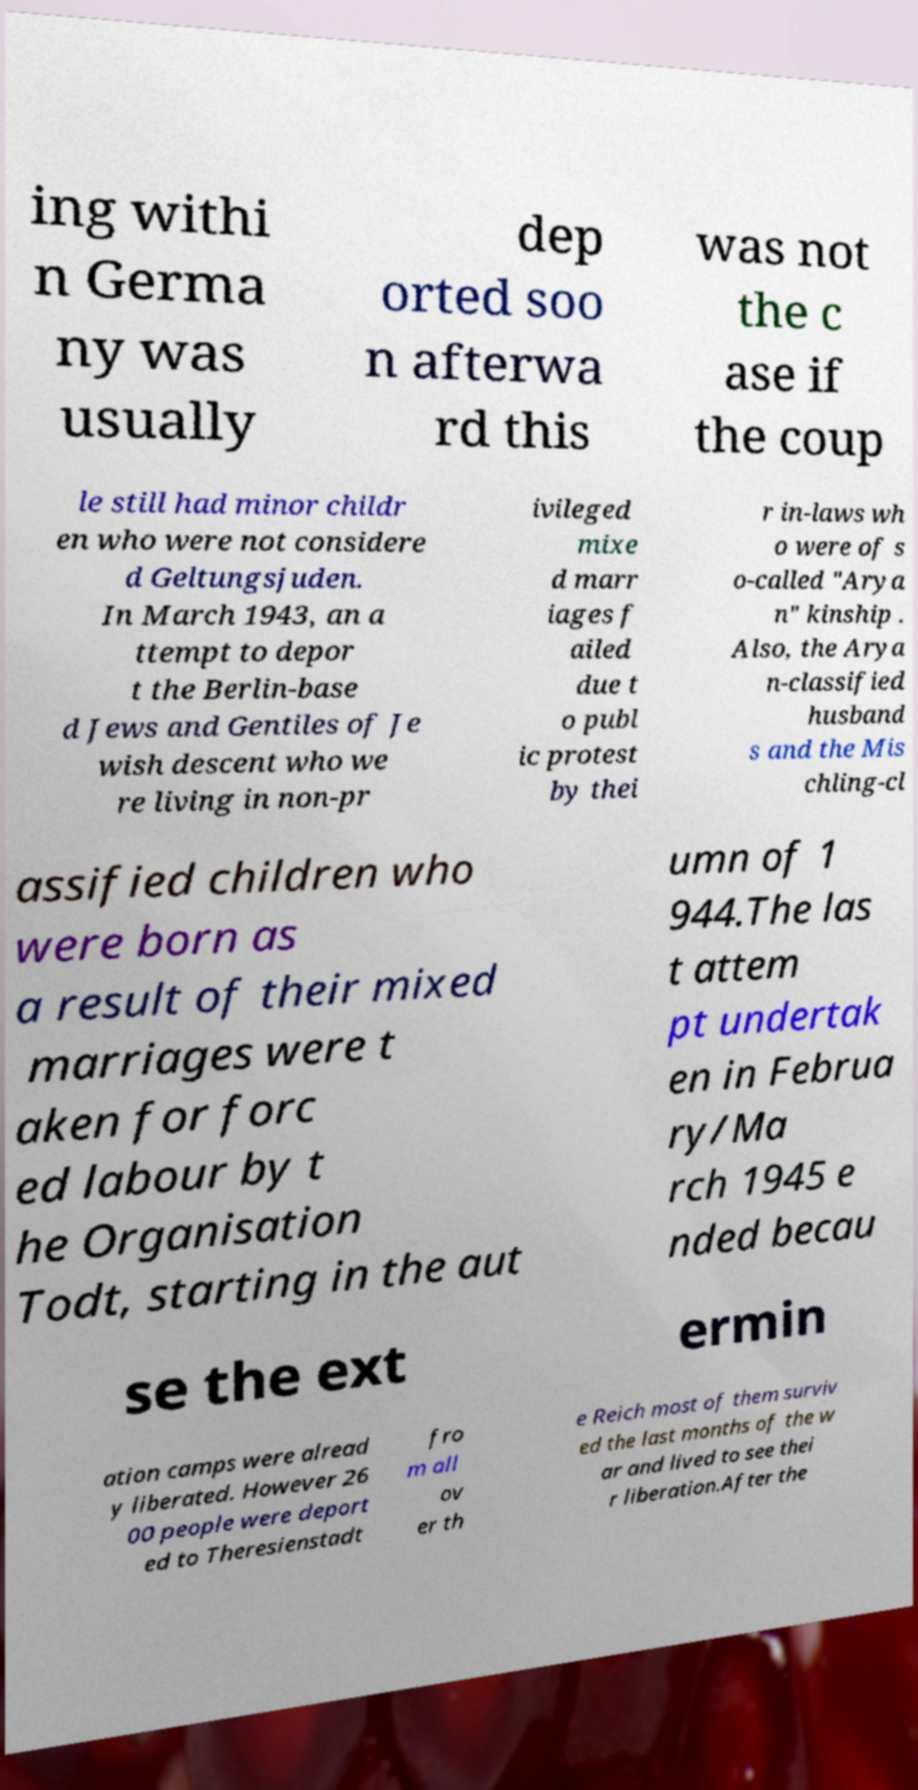Please identify and transcribe the text found in this image. ing withi n Germa ny was usually dep orted soo n afterwa rd this was not the c ase if the coup le still had minor childr en who were not considere d Geltungsjuden. In March 1943, an a ttempt to depor t the Berlin-base d Jews and Gentiles of Je wish descent who we re living in non-pr ivileged mixe d marr iages f ailed due t o publ ic protest by thei r in-laws wh o were of s o-called "Arya n" kinship . Also, the Arya n-classified husband s and the Mis chling-cl assified children who were born as a result of their mixed marriages were t aken for forc ed labour by t he Organisation Todt, starting in the aut umn of 1 944.The las t attem pt undertak en in Februa ry/Ma rch 1945 e nded becau se the ext ermin ation camps were alread y liberated. However 26 00 people were deport ed to Theresienstadt fro m all ov er th e Reich most of them surviv ed the last months of the w ar and lived to see thei r liberation.After the 